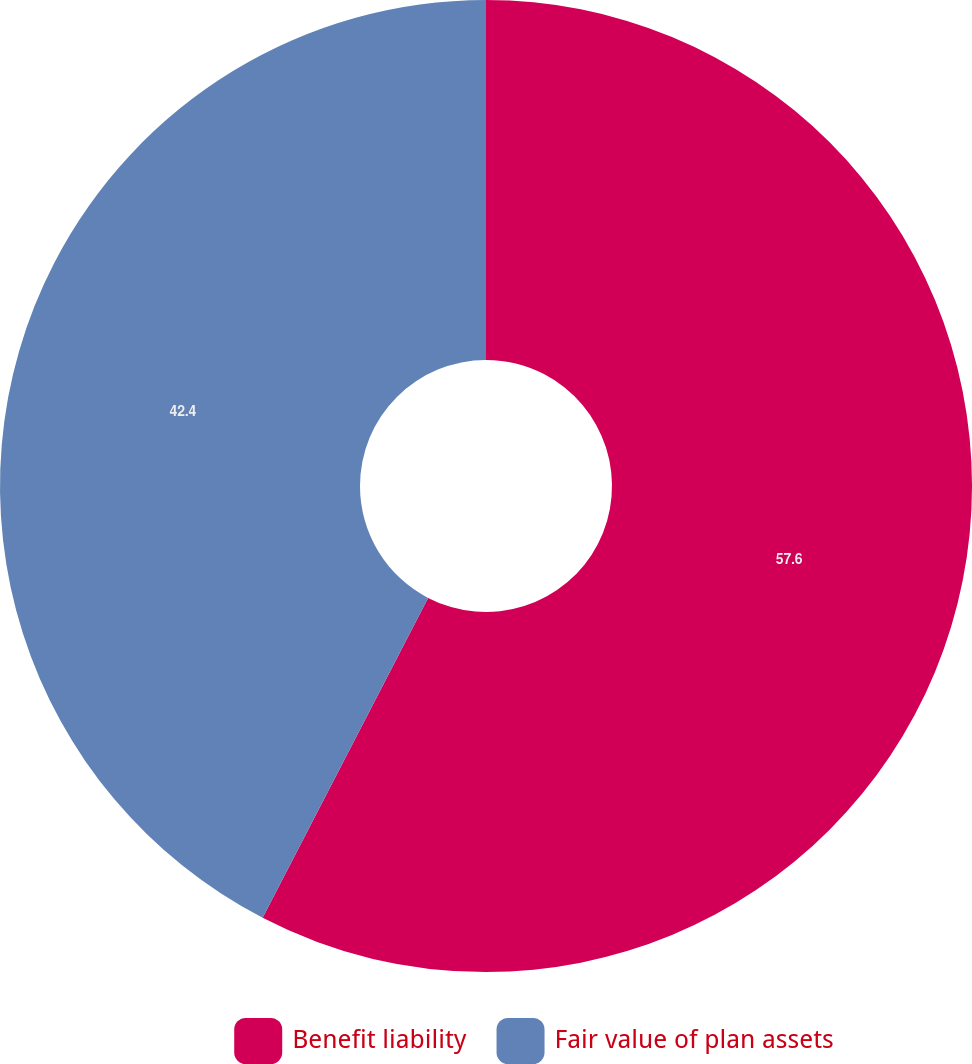Convert chart to OTSL. <chart><loc_0><loc_0><loc_500><loc_500><pie_chart><fcel>Benefit liability<fcel>Fair value of plan assets<nl><fcel>57.6%<fcel>42.4%<nl></chart> 